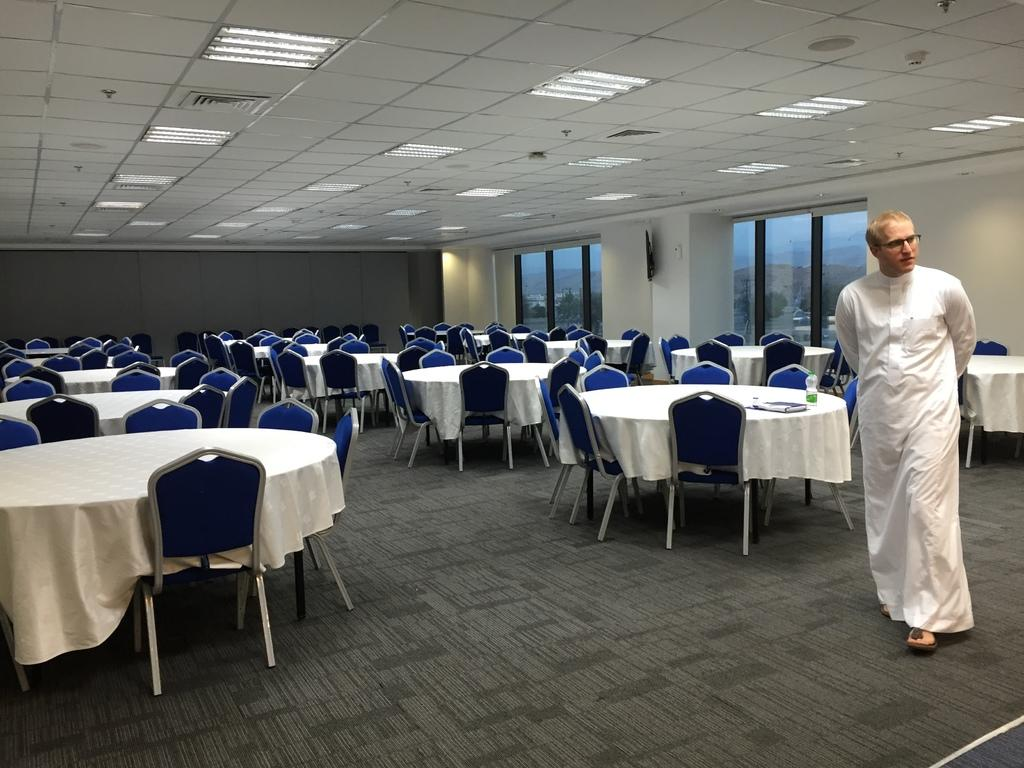What type of space is shown in the image? The image depicts a room. What furniture is present in the room? There are multiple tables and chairs in the room. Can you describe the person in the image? There is a person standing at the right side of the image, and they are wearing a white dress. What type of zebra can be seen interacting with the person in the image? There is no zebra present in the image; it only features a person standing in a room with multiple tables and chairs. 